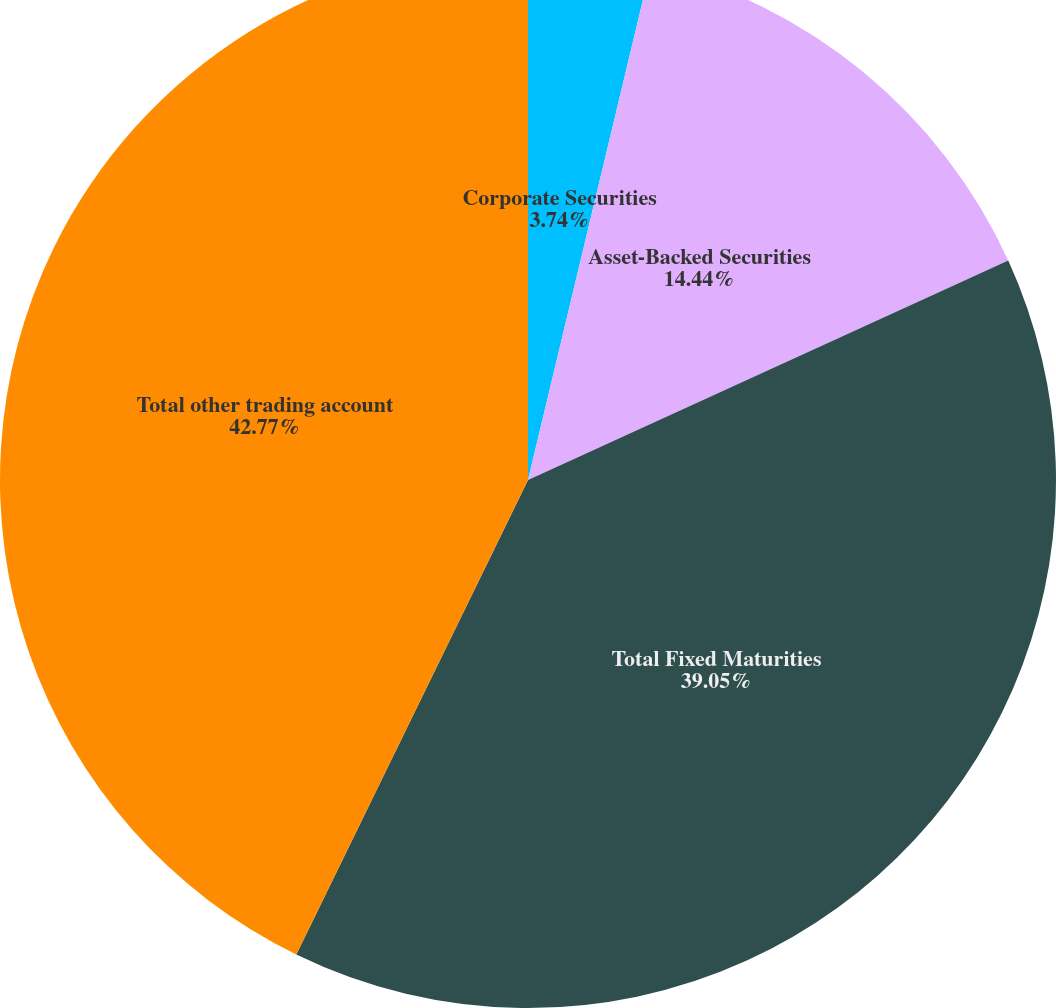Convert chart. <chart><loc_0><loc_0><loc_500><loc_500><pie_chart><fcel>Corporate Securities<fcel>Asset-Backed Securities<fcel>Total Fixed Maturities<fcel>Total other trading account<nl><fcel>3.74%<fcel>14.44%<fcel>39.05%<fcel>42.77%<nl></chart> 